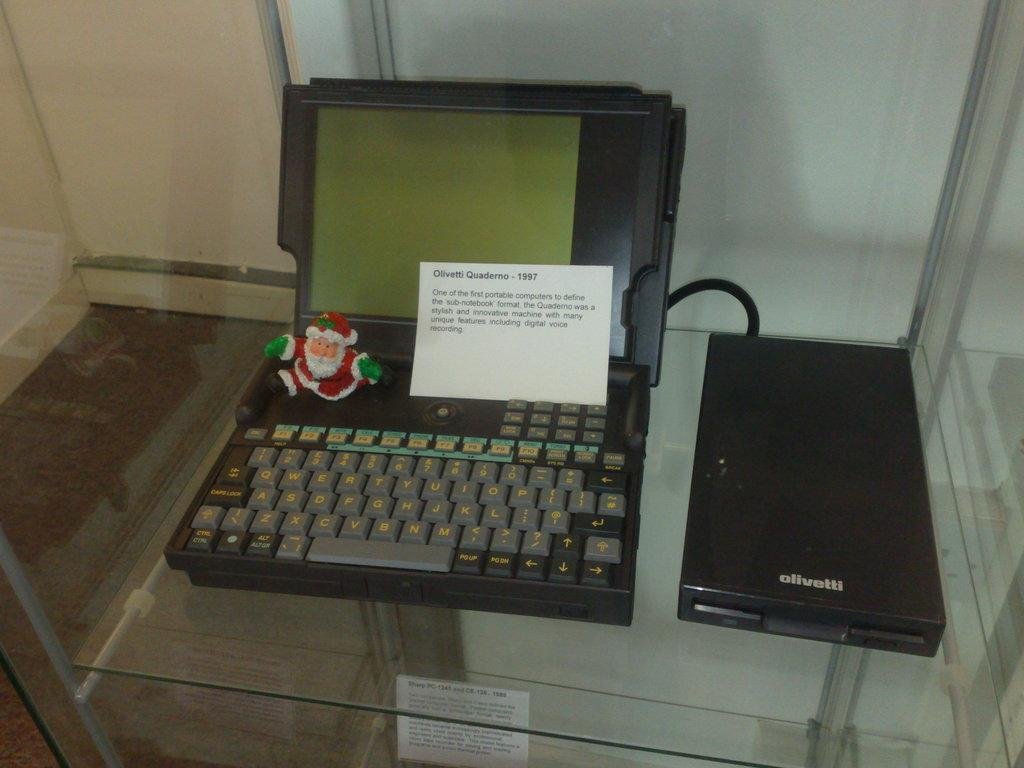<image>
Summarize the visual content of the image. An old gray and black word processor is an Olivetti brand. 